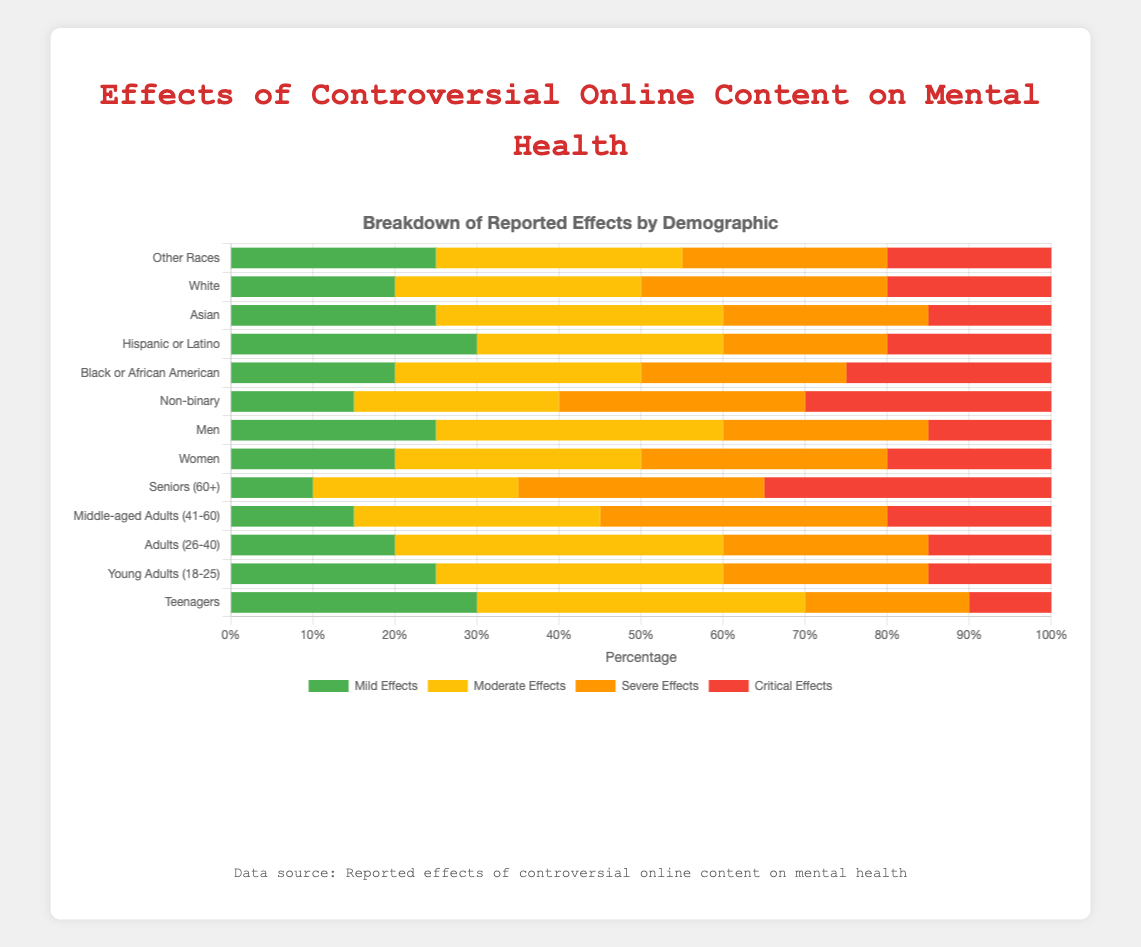What demographic has the highest percentage of critical effects? To determine which demographic has the highest percentage of critical effects, visually compare the lengths of the red (critical effects) bars. Seniors (60+) have the longest red bar, indicating they have the highest percentage.
Answer: Seniors (60+) Which demographic group reports more moderate effects: Men or Women? Compare the lengths of the yellow (moderate effects) bars for Men and Women. Men have a moderate effects value of 35, while Women have 30. Therefore, Men report more moderate effects.
Answer: Men How do the severe effects for Black or African American individuals compare to those for Asian individuals? Compare the lengths of the orange (severe effects) bars. Both demographic groups have equal lengths for severe effects, each at 25.
Answer: Equal What is the total percentage of reported effects for Teenagers exhibiting mild or moderate effects? Sum the data for mild and moderate effects for Teenagers: Mild (30) + Moderate (40) = 70.
Answer: 70% What percentage of reported effects among Middle-aged Adults (41-60) are either severe or critical? Sum the values of severe and critical effects: Severe (35) + Critical (20) = 55.
Answer: 55% Which demographic shows the least mild effects? Look for the shortest green (mild effects) bar. Seniors (60+) have the least mild effects at 10%.
Answer: Seniors (60+) Between Young Adults (18-25) and Adults (26-40), which group reports higher severe effects? Compare the orange (severe effects) bars for Young Adults (18-25) and Adults (26-40). Both groups have a severe effects percentage of 25, indicating they are equal.
Answer: Equal What is the difference in critical effects between Non-binary individuals and Men? Subtract the critical effects value of Men from Non-binary individuals: 30 - 15 = 15.
Answer: 15 